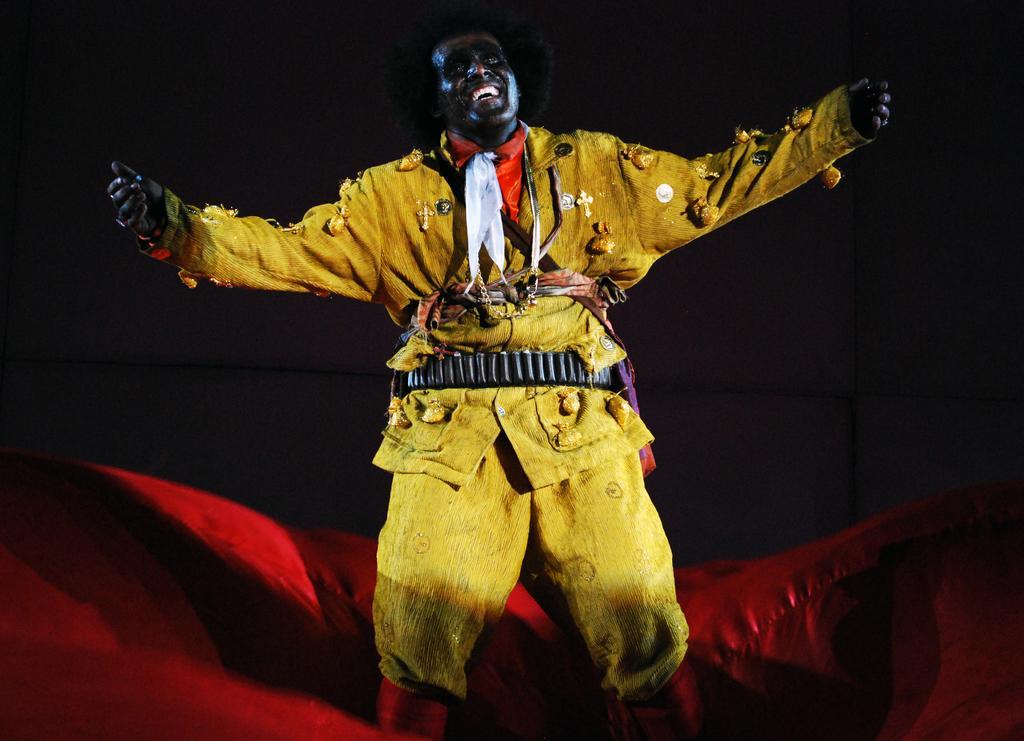Could you give a brief overview of what you see in this image? In the image there is a man with yellow dress dancing and the background is black, on the floor there is red color cloth. 